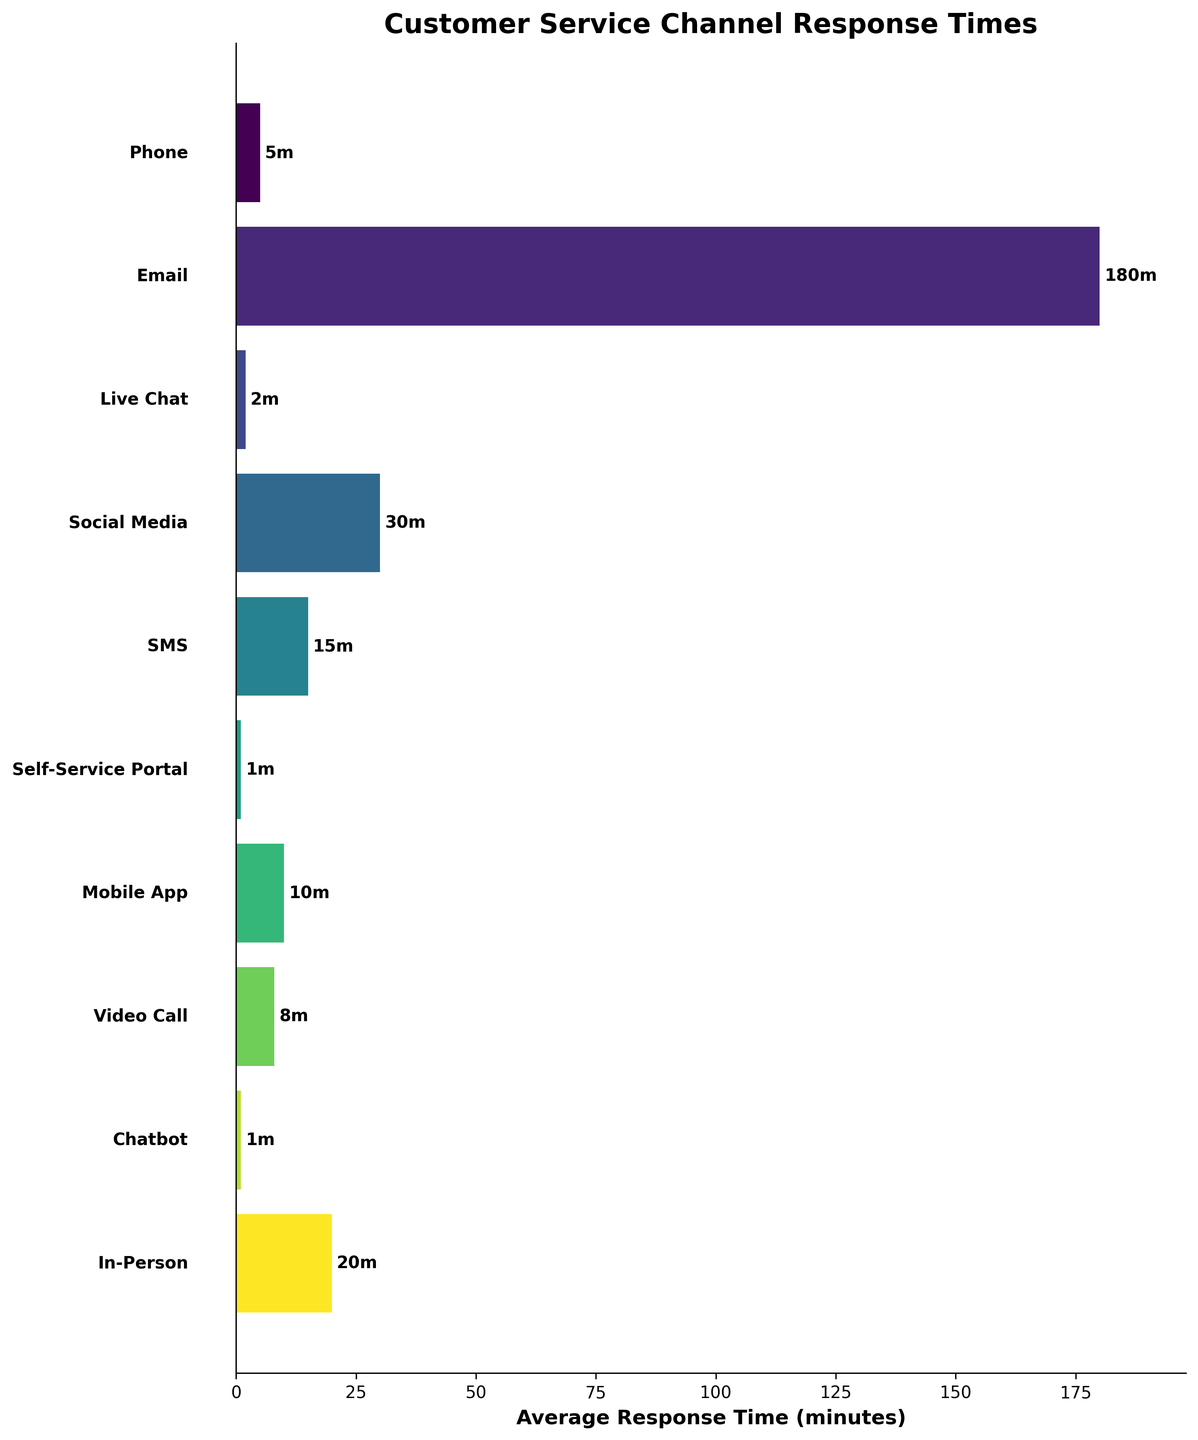What's the title of this figure? The title is explicitly written at the top of the figure in large, bold font.
Answer: Customer Service Channel Response Times Which customer service channel has the longest average response time? By inspecting the length of the horizontal bars, the longest one belongs to the 'Email' channel.
Answer: Email What is the average response time for the Phone channel? Look at the horizontal bar corresponding to the 'Phone' channel and read the text next to it, which shows the response time.
Answer: 5 minutes How many minutes faster is the Live Chat compared to the Email channel? Subtract the average response time of Live Chat (2 minutes) from that of Email (180 minutes).
Answer: 178 minutes Which two channels have the same average response time? Identify the two bars with the same length. Upon examination, we see that the 'Self-Service Portal' and 'Chatbot' have the same response time.
Answer: Self-Service Portal and Chatbot What is the total combined response time for Phone, Email, and Live Chat channels? Sum the individual response times of Phone (5 minutes), Email (180 minutes), and Live Chat (2 minutes).
Answer: 187 minutes Which service channel responds faster, SMS or Social Media? Compare the response times of SMS (15 minutes) with Social Media (30 minutes). SMS is faster.
Answer: SMS How does the response time for In-Person compare to Mobile App? Compare the response times provided in the chart: In-Person is 20 minutes, and Mobile App is 10 minutes.
Answer: In-Person is slower Out of all customer service channels, which channel typically has the quickest response time? Identify the channel with the shortest horizontal bar, which is the 'Self-Service Portal' and 'Chatbot', both showing 1 minute.
Answer: Self-Service Portal and Chatbot What is the range of response times among the different customer service channels? Find the difference between the maximum (Email, 180 minutes) and minimum (Self-Service Portal or Chatbot, 1 minute) response times.
Answer: 179 minutes 